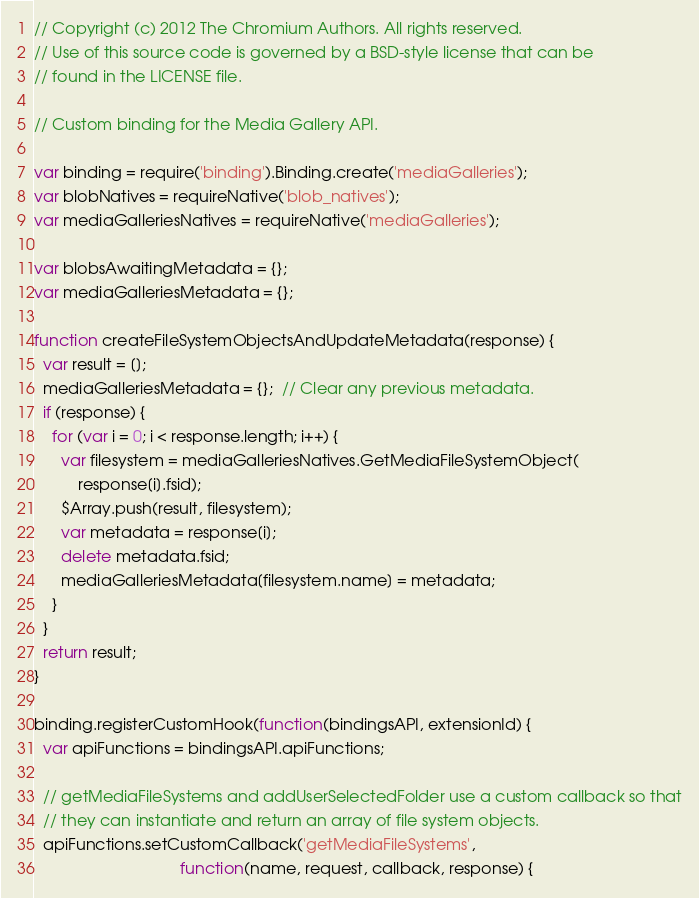Convert code to text. <code><loc_0><loc_0><loc_500><loc_500><_JavaScript_>// Copyright (c) 2012 The Chromium Authors. All rights reserved.
// Use of this source code is governed by a BSD-style license that can be
// found in the LICENSE file.

// Custom binding for the Media Gallery API.

var binding = require('binding').Binding.create('mediaGalleries');
var blobNatives = requireNative('blob_natives');
var mediaGalleriesNatives = requireNative('mediaGalleries');

var blobsAwaitingMetadata = {};
var mediaGalleriesMetadata = {};

function createFileSystemObjectsAndUpdateMetadata(response) {
  var result = [];
  mediaGalleriesMetadata = {};  // Clear any previous metadata.
  if (response) {
    for (var i = 0; i < response.length; i++) {
      var filesystem = mediaGalleriesNatives.GetMediaFileSystemObject(
          response[i].fsid);
      $Array.push(result, filesystem);
      var metadata = response[i];
      delete metadata.fsid;
      mediaGalleriesMetadata[filesystem.name] = metadata;
    }
  }
  return result;
}

binding.registerCustomHook(function(bindingsAPI, extensionId) {
  var apiFunctions = bindingsAPI.apiFunctions;

  // getMediaFileSystems and addUserSelectedFolder use a custom callback so that
  // they can instantiate and return an array of file system objects.
  apiFunctions.setCustomCallback('getMediaFileSystems',
                                 function(name, request, callback, response) {</code> 